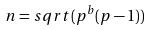Convert formula to latex. <formula><loc_0><loc_0><loc_500><loc_500>n = s q r t ( p ^ { b } ( p - 1 ) )</formula> 